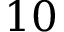<formula> <loc_0><loc_0><loc_500><loc_500>1 0</formula> 